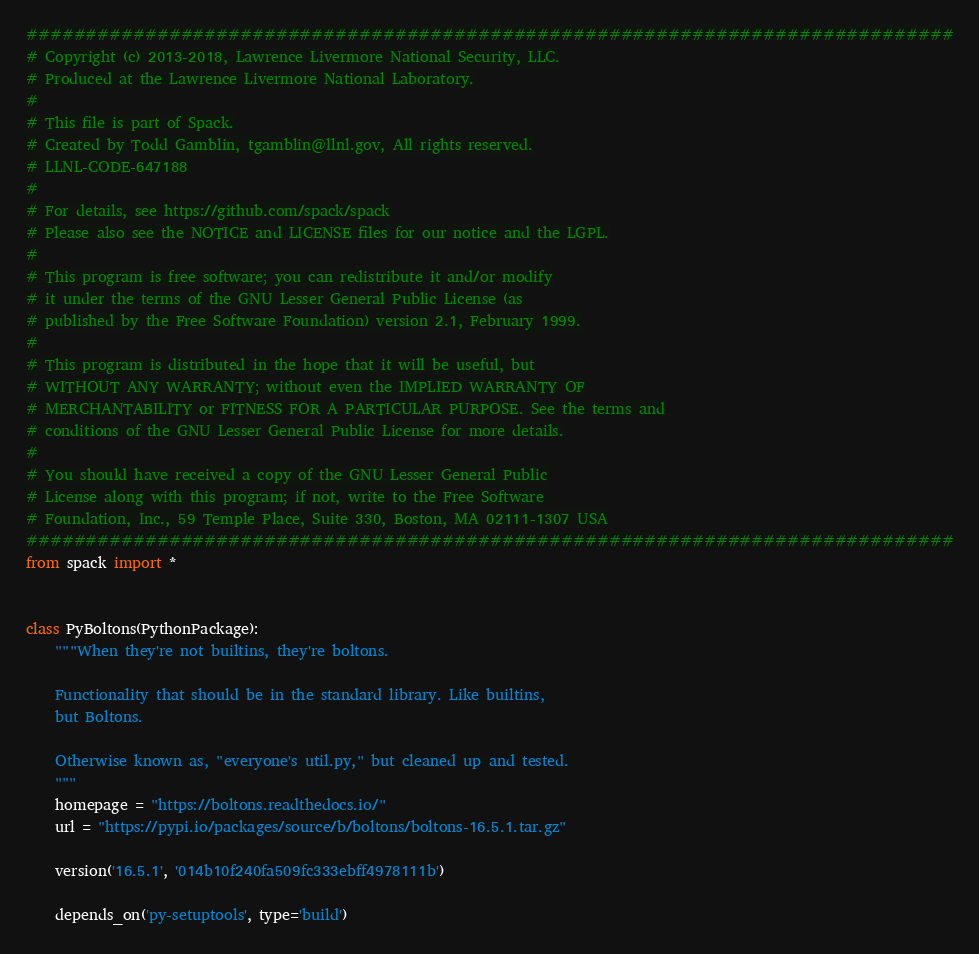Convert code to text. <code><loc_0><loc_0><loc_500><loc_500><_Python_>##############################################################################
# Copyright (c) 2013-2018, Lawrence Livermore National Security, LLC.
# Produced at the Lawrence Livermore National Laboratory.
#
# This file is part of Spack.
# Created by Todd Gamblin, tgamblin@llnl.gov, All rights reserved.
# LLNL-CODE-647188
#
# For details, see https://github.com/spack/spack
# Please also see the NOTICE and LICENSE files for our notice and the LGPL.
#
# This program is free software; you can redistribute it and/or modify
# it under the terms of the GNU Lesser General Public License (as
# published by the Free Software Foundation) version 2.1, February 1999.
#
# This program is distributed in the hope that it will be useful, but
# WITHOUT ANY WARRANTY; without even the IMPLIED WARRANTY OF
# MERCHANTABILITY or FITNESS FOR A PARTICULAR PURPOSE. See the terms and
# conditions of the GNU Lesser General Public License for more details.
#
# You should have received a copy of the GNU Lesser General Public
# License along with this program; if not, write to the Free Software
# Foundation, Inc., 59 Temple Place, Suite 330, Boston, MA 02111-1307 USA
##############################################################################
from spack import *


class PyBoltons(PythonPackage):
    """When they're not builtins, they're boltons.

    Functionality that should be in the standard library. Like builtins,
    but Boltons.

    Otherwise known as, "everyone's util.py," but cleaned up and tested.
    """
    homepage = "https://boltons.readthedocs.io/"
    url = "https://pypi.io/packages/source/b/boltons/boltons-16.5.1.tar.gz"

    version('16.5.1', '014b10f240fa509fc333ebff4978111b')

    depends_on('py-setuptools', type='build')
</code> 